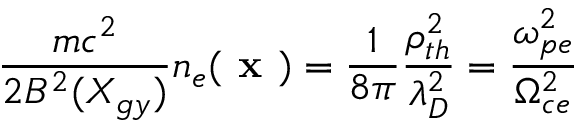Convert formula to latex. <formula><loc_0><loc_0><loc_500><loc_500>\frac { m c ^ { 2 } } { 2 B ^ { 2 } ( X _ { g y } ) } n _ { e } ( x ) = \frac { 1 } { 8 \pi } \frac { \rho _ { t h } ^ { 2 } } { \lambda _ { D } ^ { 2 } } = \frac { \omega _ { p e } ^ { 2 } } { \Omega _ { c e } ^ { 2 } }</formula> 